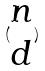<formula> <loc_0><loc_0><loc_500><loc_500>( \begin{matrix} n \\ d \end{matrix} )</formula> 